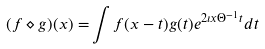<formula> <loc_0><loc_0><loc_500><loc_500>( f \diamond g ) ( x ) = & \int f ( x - t ) g ( t ) e ^ { 2 \imath x \Theta ^ { - 1 } t } d t</formula> 